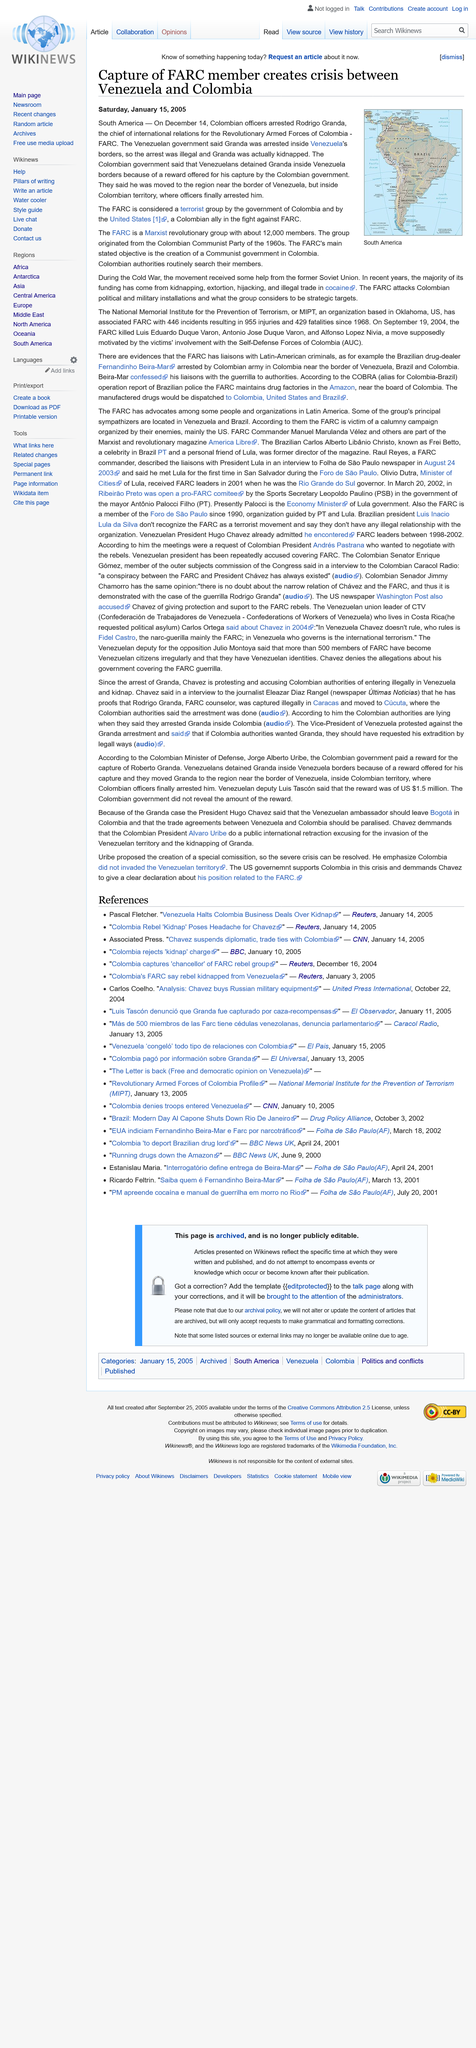Indicate a few pertinent items in this graphic. The primary objective of FARC is to establish a communist government in Colombia. Rodrigo Granda served as the chief of international relations for the Revolutionary Armed Forces of Colombia (FARC). Rodrigo Granda was arrested on December 14, 2005. 